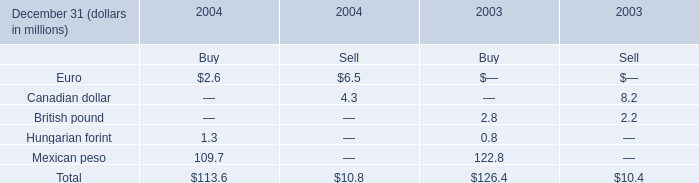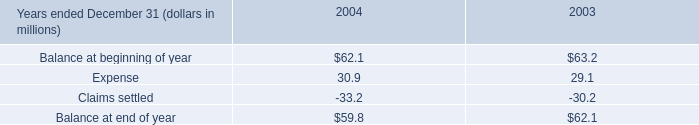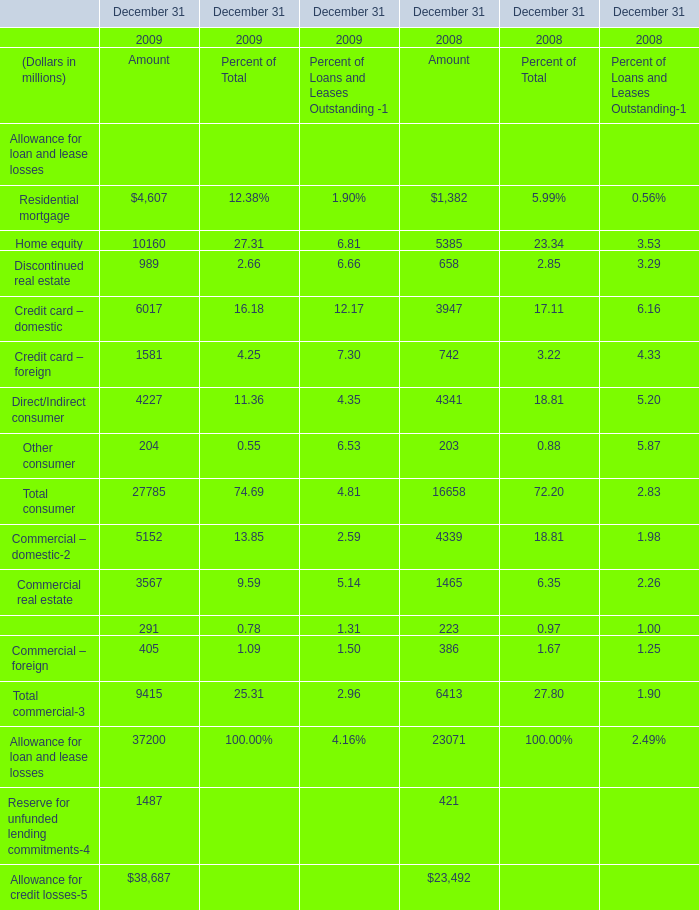What's the total amount of the Discontinued real estate for Amount in the years where Home equity is greater than 5000? (in million) 
Computations: (989 + 658)
Answer: 1647.0. 